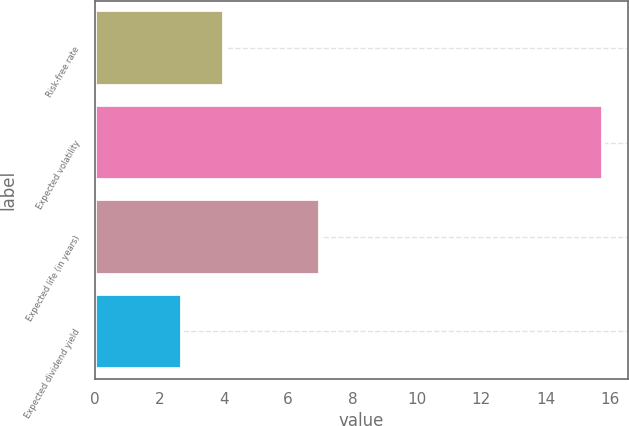Convert chart to OTSL. <chart><loc_0><loc_0><loc_500><loc_500><bar_chart><fcel>Risk-free rate<fcel>Expected volatility<fcel>Expected life (in years)<fcel>Expected dividend yield<nl><fcel>4.01<fcel>15.77<fcel>7<fcel>2.7<nl></chart> 